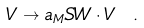Convert formula to latex. <formula><loc_0><loc_0><loc_500><loc_500>V \to a _ { M } S W \cdot V \ .</formula> 